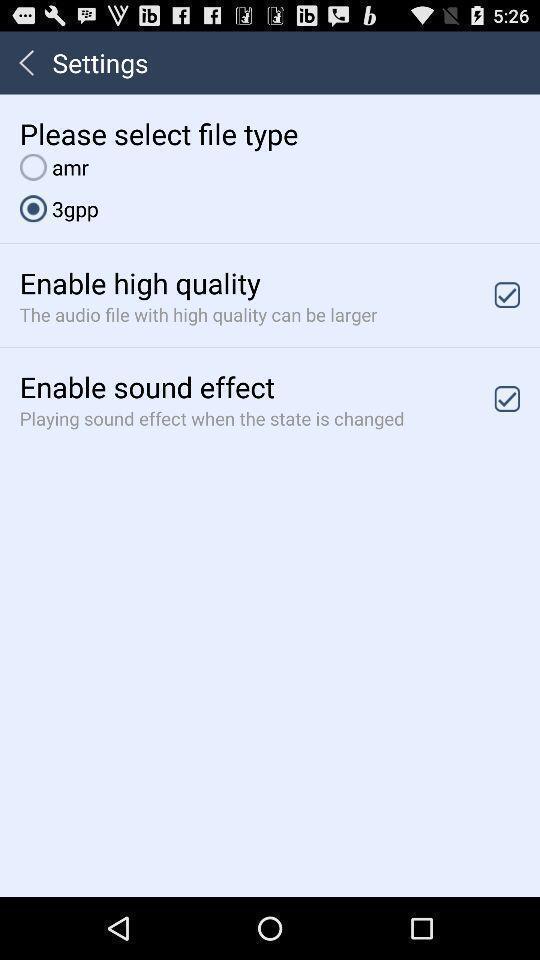Provide a description of this screenshot. Settings page with various options. 